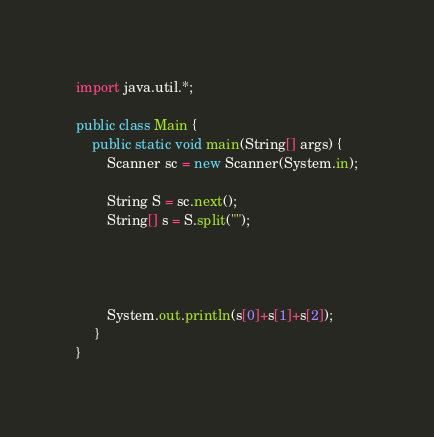Convert code to text. <code><loc_0><loc_0><loc_500><loc_500><_Java_>import java.util.*;

public class Main {
    public static void main(String[] args) {
        Scanner sc = new Scanner(System.in);
        
        String S = sc.next();
        String[] s = S.split("");
        
        
        
        
        System.out.println(s[0]+s[1]+s[2]);
     }
}</code> 